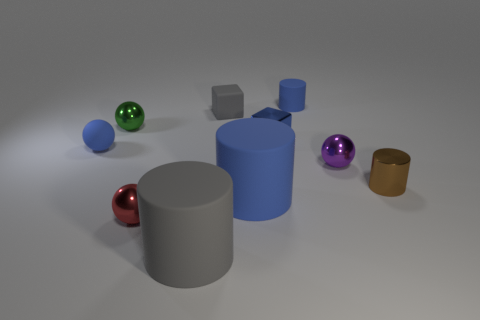How many other small objects have the same shape as the small purple thing?
Provide a short and direct response. 3. There is a sphere in front of the small brown cylinder; how many tiny blue matte balls are on the right side of it?
Give a very brief answer. 0. How many matte objects are either blue things or large objects?
Make the answer very short. 4. Are there any tiny yellow cylinders that have the same material as the tiny green object?
Ensure brevity in your answer.  No. How many objects are either tiny shiny balls that are behind the brown cylinder or blue cylinders on the left side of the tiny brown shiny cylinder?
Your response must be concise. 4. There is a tiny cylinder that is in front of the metal cube; is it the same color as the small shiny cube?
Your answer should be compact. No. How many other things are the same color as the rubber block?
Ensure brevity in your answer.  1. What is the brown cylinder made of?
Keep it short and to the point. Metal. There is a sphere right of the red sphere; does it have the same size as the blue block?
Your answer should be very brief. Yes. There is another blue object that is the same shape as the large blue rubber object; what size is it?
Offer a very short reply. Small. 